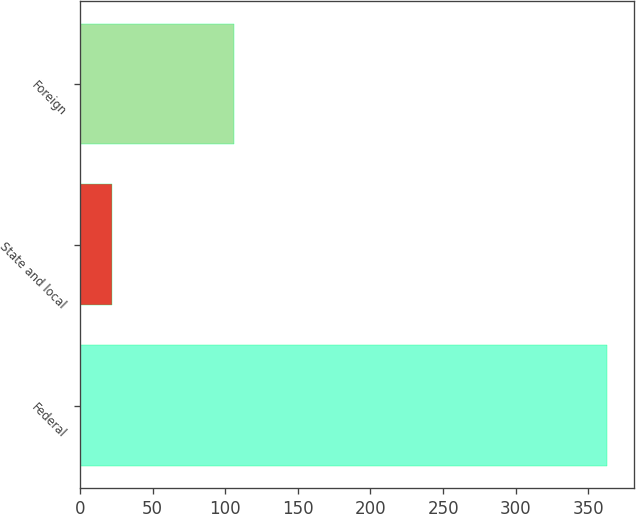<chart> <loc_0><loc_0><loc_500><loc_500><bar_chart><fcel>Federal<fcel>State and local<fcel>Foreign<nl><fcel>363<fcel>22<fcel>106<nl></chart> 